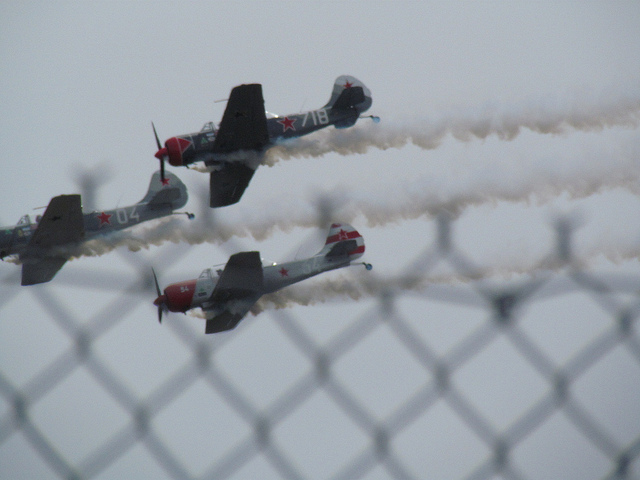How many airplanes are in the photo? There are three airplanes in the photo, each performing with white smoke trails, likely part of an aerial show or display. 